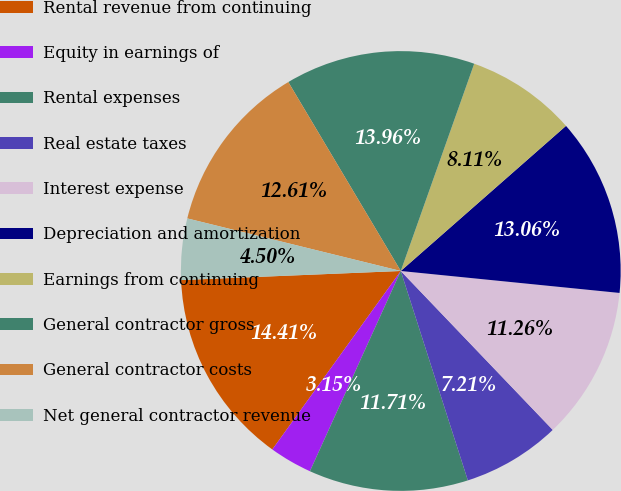Convert chart to OTSL. <chart><loc_0><loc_0><loc_500><loc_500><pie_chart><fcel>Rental revenue from continuing<fcel>Equity in earnings of<fcel>Rental expenses<fcel>Real estate taxes<fcel>Interest expense<fcel>Depreciation and amortization<fcel>Earnings from continuing<fcel>General contractor gross<fcel>General contractor costs<fcel>Net general contractor revenue<nl><fcel>14.41%<fcel>3.15%<fcel>11.71%<fcel>7.21%<fcel>11.26%<fcel>13.06%<fcel>8.11%<fcel>13.96%<fcel>12.61%<fcel>4.5%<nl></chart> 